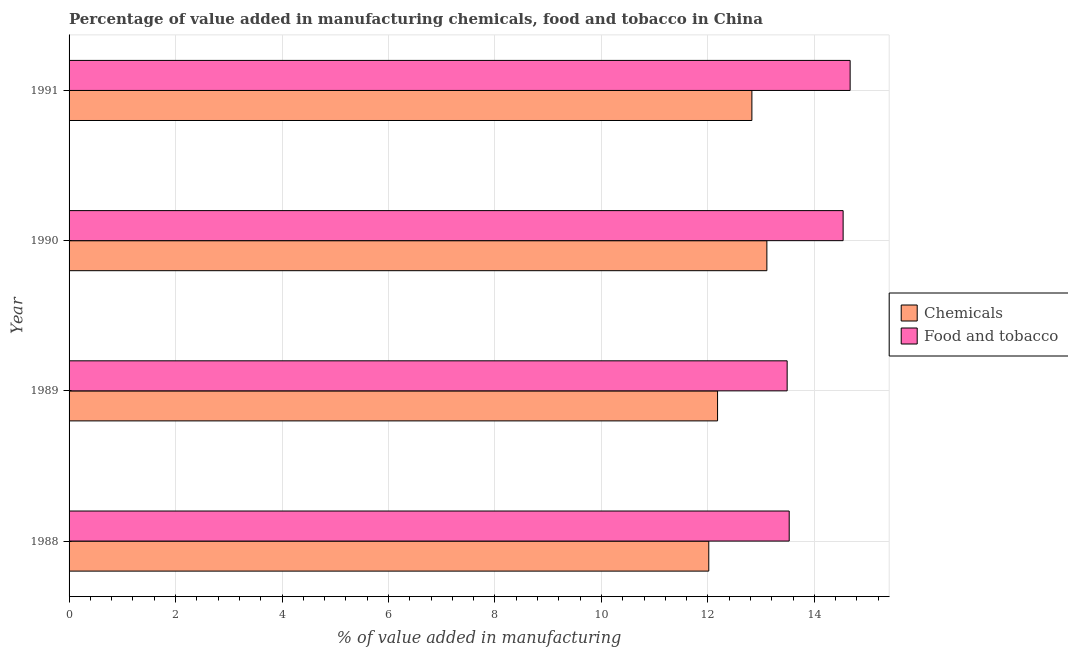Are the number of bars per tick equal to the number of legend labels?
Provide a short and direct response. Yes. Are the number of bars on each tick of the Y-axis equal?
Provide a succinct answer. Yes. How many bars are there on the 1st tick from the top?
Provide a short and direct response. 2. How many bars are there on the 2nd tick from the bottom?
Provide a short and direct response. 2. In how many cases, is the number of bars for a given year not equal to the number of legend labels?
Offer a terse response. 0. What is the value added by manufacturing food and tobacco in 1991?
Give a very brief answer. 14.67. Across all years, what is the maximum value added by manufacturing food and tobacco?
Your answer should be very brief. 14.67. Across all years, what is the minimum value added by manufacturing food and tobacco?
Ensure brevity in your answer.  13.49. In which year was the value added by  manufacturing chemicals minimum?
Offer a terse response. 1988. What is the total value added by  manufacturing chemicals in the graph?
Your answer should be very brief. 50.13. What is the difference between the value added by  manufacturing chemicals in 1988 and that in 1991?
Offer a very short reply. -0.81. What is the difference between the value added by manufacturing food and tobacco in 1988 and the value added by  manufacturing chemicals in 1990?
Offer a terse response. 0.42. What is the average value added by  manufacturing chemicals per year?
Your answer should be very brief. 12.53. In the year 1989, what is the difference between the value added by  manufacturing chemicals and value added by manufacturing food and tobacco?
Provide a short and direct response. -1.31. In how many years, is the value added by manufacturing food and tobacco greater than 12.4 %?
Your response must be concise. 4. What is the ratio of the value added by  manufacturing chemicals in 1988 to that in 1991?
Keep it short and to the point. 0.94. Is the value added by manufacturing food and tobacco in 1988 less than that in 1991?
Keep it short and to the point. Yes. What is the difference between the highest and the second highest value added by  manufacturing chemicals?
Offer a very short reply. 0.28. What is the difference between the highest and the lowest value added by  manufacturing chemicals?
Provide a short and direct response. 1.09. What does the 1st bar from the top in 1991 represents?
Offer a terse response. Food and tobacco. What does the 2nd bar from the bottom in 1988 represents?
Offer a very short reply. Food and tobacco. Are all the bars in the graph horizontal?
Provide a short and direct response. Yes. How many years are there in the graph?
Give a very brief answer. 4. What is the difference between two consecutive major ticks on the X-axis?
Provide a short and direct response. 2. What is the title of the graph?
Give a very brief answer. Percentage of value added in manufacturing chemicals, food and tobacco in China. Does "From human activities" appear as one of the legend labels in the graph?
Ensure brevity in your answer.  No. What is the label or title of the X-axis?
Your answer should be very brief. % of value added in manufacturing. What is the % of value added in manufacturing in Chemicals in 1988?
Keep it short and to the point. 12.02. What is the % of value added in manufacturing in Food and tobacco in 1988?
Your answer should be very brief. 13.53. What is the % of value added in manufacturing in Chemicals in 1989?
Your answer should be compact. 12.18. What is the % of value added in manufacturing in Food and tobacco in 1989?
Give a very brief answer. 13.49. What is the % of value added in manufacturing in Chemicals in 1990?
Your response must be concise. 13.11. What is the % of value added in manufacturing of Food and tobacco in 1990?
Provide a short and direct response. 14.54. What is the % of value added in manufacturing in Chemicals in 1991?
Offer a very short reply. 12.83. What is the % of value added in manufacturing in Food and tobacco in 1991?
Keep it short and to the point. 14.67. Across all years, what is the maximum % of value added in manufacturing in Chemicals?
Provide a short and direct response. 13.11. Across all years, what is the maximum % of value added in manufacturing in Food and tobacco?
Make the answer very short. 14.67. Across all years, what is the minimum % of value added in manufacturing of Chemicals?
Offer a very short reply. 12.02. Across all years, what is the minimum % of value added in manufacturing in Food and tobacco?
Your response must be concise. 13.49. What is the total % of value added in manufacturing of Chemicals in the graph?
Make the answer very short. 50.13. What is the total % of value added in manufacturing in Food and tobacco in the graph?
Provide a short and direct response. 56.23. What is the difference between the % of value added in manufacturing of Chemicals in 1988 and that in 1989?
Keep it short and to the point. -0.17. What is the difference between the % of value added in manufacturing of Food and tobacco in 1988 and that in 1989?
Offer a very short reply. 0.04. What is the difference between the % of value added in manufacturing of Chemicals in 1988 and that in 1990?
Offer a terse response. -1.09. What is the difference between the % of value added in manufacturing in Food and tobacco in 1988 and that in 1990?
Provide a short and direct response. -1.01. What is the difference between the % of value added in manufacturing in Chemicals in 1988 and that in 1991?
Offer a very short reply. -0.81. What is the difference between the % of value added in manufacturing of Food and tobacco in 1988 and that in 1991?
Provide a succinct answer. -1.14. What is the difference between the % of value added in manufacturing of Chemicals in 1989 and that in 1990?
Offer a very short reply. -0.93. What is the difference between the % of value added in manufacturing of Food and tobacco in 1989 and that in 1990?
Your answer should be very brief. -1.05. What is the difference between the % of value added in manufacturing in Chemicals in 1989 and that in 1991?
Provide a succinct answer. -0.64. What is the difference between the % of value added in manufacturing of Food and tobacco in 1989 and that in 1991?
Your answer should be compact. -1.18. What is the difference between the % of value added in manufacturing in Chemicals in 1990 and that in 1991?
Your answer should be very brief. 0.28. What is the difference between the % of value added in manufacturing of Food and tobacco in 1990 and that in 1991?
Ensure brevity in your answer.  -0.13. What is the difference between the % of value added in manufacturing of Chemicals in 1988 and the % of value added in manufacturing of Food and tobacco in 1989?
Your response must be concise. -1.47. What is the difference between the % of value added in manufacturing in Chemicals in 1988 and the % of value added in manufacturing in Food and tobacco in 1990?
Your answer should be compact. -2.52. What is the difference between the % of value added in manufacturing of Chemicals in 1988 and the % of value added in manufacturing of Food and tobacco in 1991?
Ensure brevity in your answer.  -2.66. What is the difference between the % of value added in manufacturing of Chemicals in 1989 and the % of value added in manufacturing of Food and tobacco in 1990?
Your answer should be compact. -2.36. What is the difference between the % of value added in manufacturing in Chemicals in 1989 and the % of value added in manufacturing in Food and tobacco in 1991?
Your answer should be very brief. -2.49. What is the difference between the % of value added in manufacturing of Chemicals in 1990 and the % of value added in manufacturing of Food and tobacco in 1991?
Provide a succinct answer. -1.56. What is the average % of value added in manufacturing of Chemicals per year?
Provide a short and direct response. 12.53. What is the average % of value added in manufacturing in Food and tobacco per year?
Provide a short and direct response. 14.06. In the year 1988, what is the difference between the % of value added in manufacturing in Chemicals and % of value added in manufacturing in Food and tobacco?
Provide a short and direct response. -1.51. In the year 1989, what is the difference between the % of value added in manufacturing of Chemicals and % of value added in manufacturing of Food and tobacco?
Offer a very short reply. -1.31. In the year 1990, what is the difference between the % of value added in manufacturing of Chemicals and % of value added in manufacturing of Food and tobacco?
Your answer should be very brief. -1.43. In the year 1991, what is the difference between the % of value added in manufacturing in Chemicals and % of value added in manufacturing in Food and tobacco?
Keep it short and to the point. -1.85. What is the ratio of the % of value added in manufacturing in Chemicals in 1988 to that in 1989?
Your answer should be compact. 0.99. What is the ratio of the % of value added in manufacturing of Food and tobacco in 1988 to that in 1989?
Your answer should be compact. 1. What is the ratio of the % of value added in manufacturing of Food and tobacco in 1988 to that in 1990?
Your answer should be very brief. 0.93. What is the ratio of the % of value added in manufacturing in Chemicals in 1988 to that in 1991?
Offer a terse response. 0.94. What is the ratio of the % of value added in manufacturing in Food and tobacco in 1988 to that in 1991?
Offer a terse response. 0.92. What is the ratio of the % of value added in manufacturing of Chemicals in 1989 to that in 1990?
Ensure brevity in your answer.  0.93. What is the ratio of the % of value added in manufacturing in Food and tobacco in 1989 to that in 1990?
Make the answer very short. 0.93. What is the ratio of the % of value added in manufacturing in Chemicals in 1989 to that in 1991?
Ensure brevity in your answer.  0.95. What is the ratio of the % of value added in manufacturing in Food and tobacco in 1989 to that in 1991?
Your answer should be very brief. 0.92. What is the ratio of the % of value added in manufacturing in Chemicals in 1990 to that in 1991?
Provide a succinct answer. 1.02. What is the ratio of the % of value added in manufacturing in Food and tobacco in 1990 to that in 1991?
Offer a terse response. 0.99. What is the difference between the highest and the second highest % of value added in manufacturing of Chemicals?
Provide a succinct answer. 0.28. What is the difference between the highest and the second highest % of value added in manufacturing of Food and tobacco?
Your response must be concise. 0.13. What is the difference between the highest and the lowest % of value added in manufacturing of Chemicals?
Your response must be concise. 1.09. What is the difference between the highest and the lowest % of value added in manufacturing of Food and tobacco?
Your answer should be very brief. 1.18. 